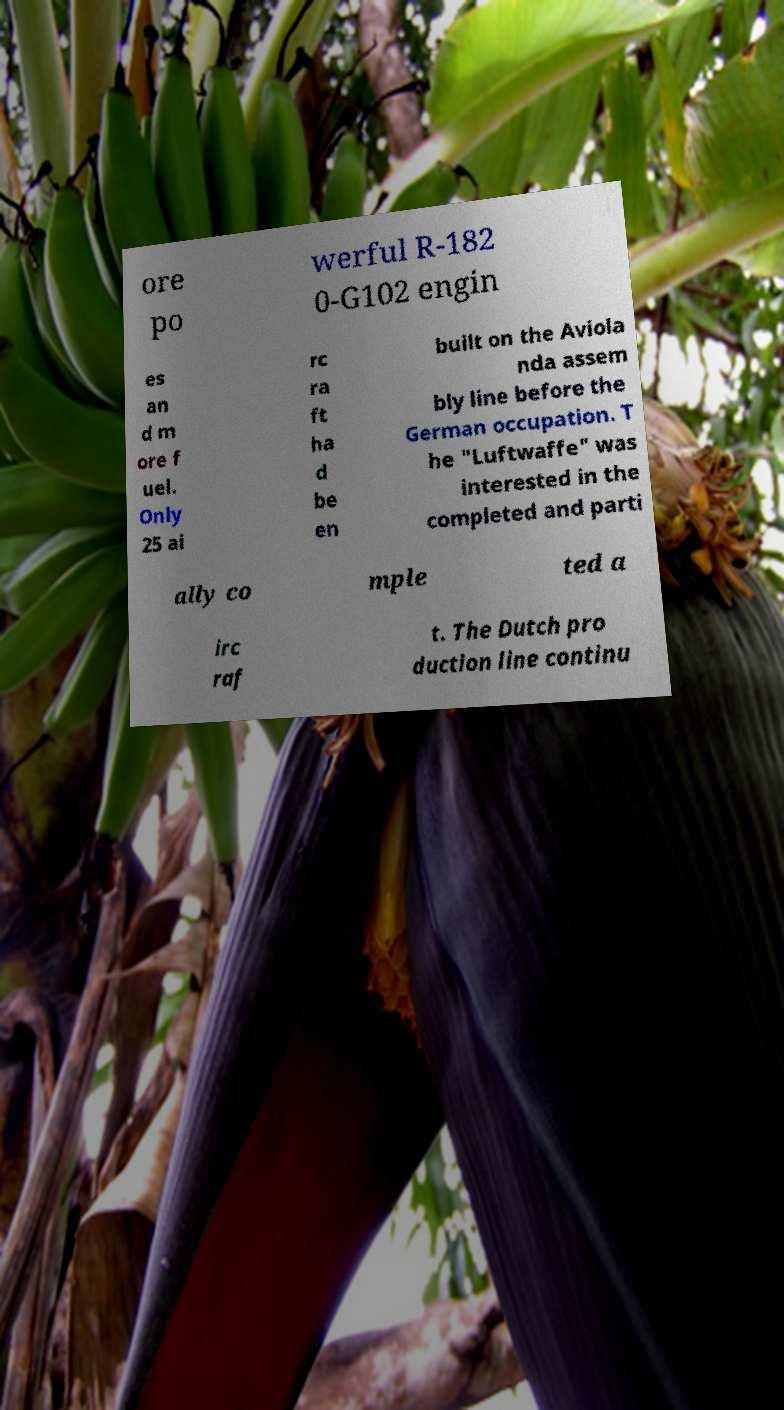Could you assist in decoding the text presented in this image and type it out clearly? ore po werful R-182 0-G102 engin es an d m ore f uel. Only 25 ai rc ra ft ha d be en built on the Aviola nda assem bly line before the German occupation. T he "Luftwaffe" was interested in the completed and parti ally co mple ted a irc raf t. The Dutch pro duction line continu 